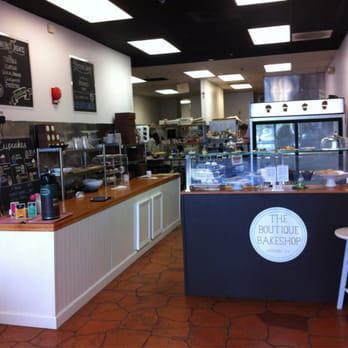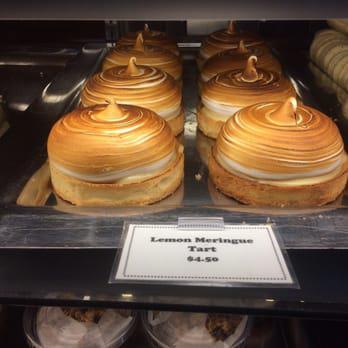The first image is the image on the left, the second image is the image on the right. Evaluate the accuracy of this statement regarding the images: "An image shows a female worker by a glass case, wearing a scarf on her head.". Is it true? Answer yes or no. No. The first image is the image on the left, the second image is the image on the right. Assess this claim about the two images: "a woman behind the counter is wearing a head wrap.". Correct or not? Answer yes or no. No. 